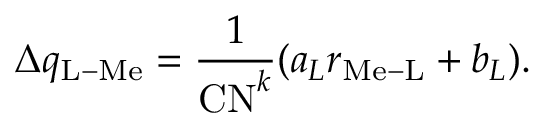Convert formula to latex. <formula><loc_0><loc_0><loc_500><loc_500>\Delta q _ { L - M e } = \frac { 1 } { C N ^ { k } } ( a _ { L } r _ { M e - L } + b _ { L } ) .</formula> 